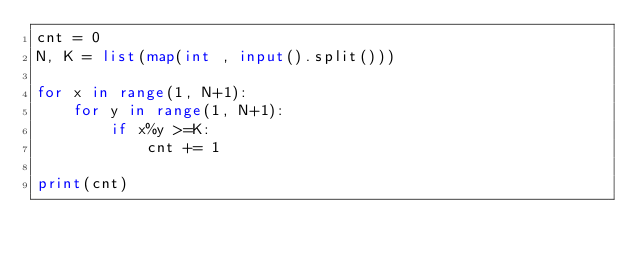<code> <loc_0><loc_0><loc_500><loc_500><_Python_>cnt = 0
N, K = list(map(int , input().split()))

for x in range(1, N+1):
    for y in range(1, N+1):
        if x%y >=K:
            cnt += 1

print(cnt)</code> 